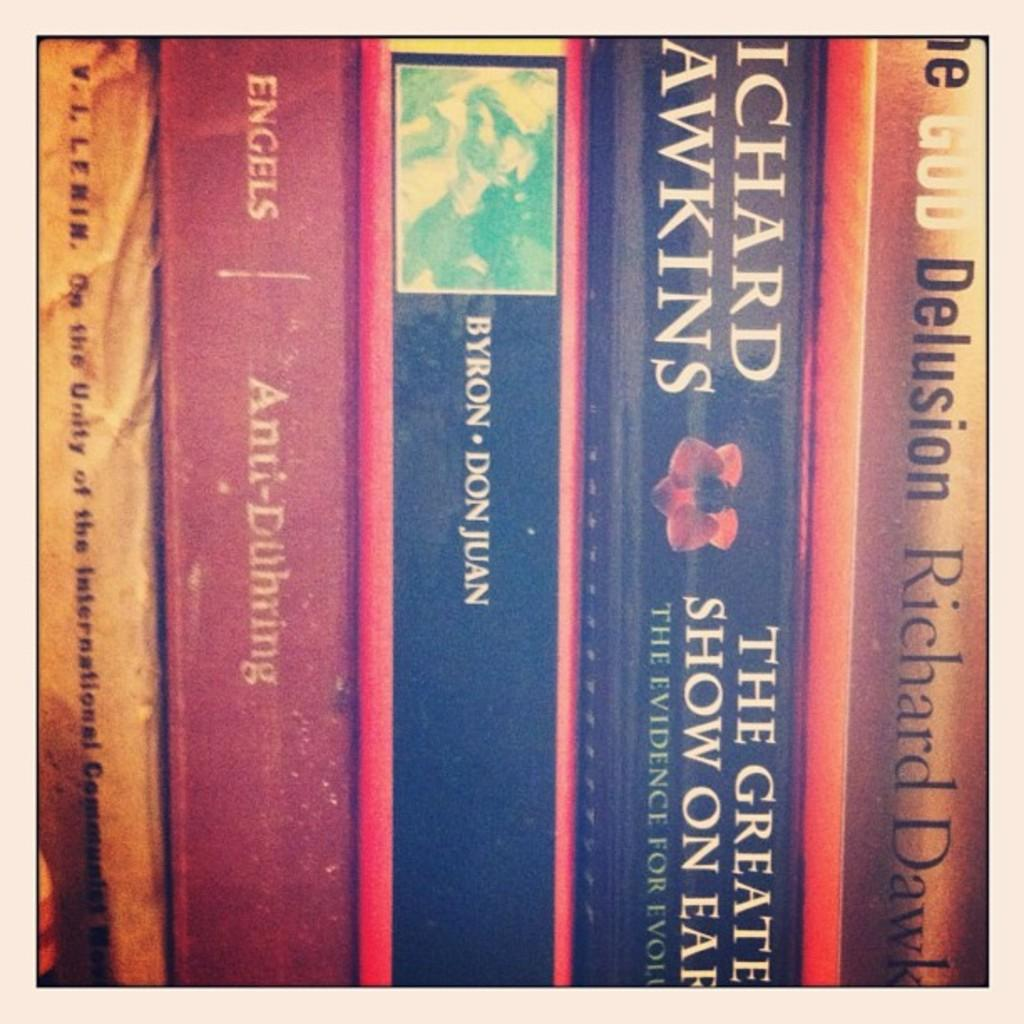<image>
Present a compact description of the photo's key features. Several books include Richard Dawkins among their authors. 